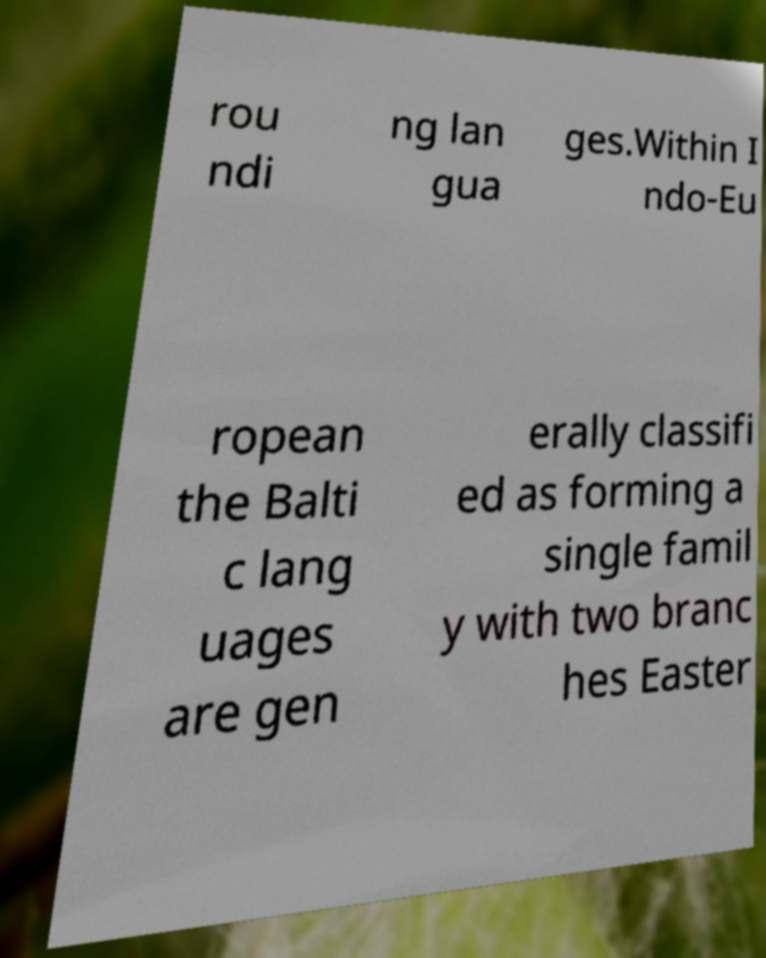Please identify and transcribe the text found in this image. rou ndi ng lan gua ges.Within I ndo-Eu ropean the Balti c lang uages are gen erally classifi ed as forming a single famil y with two branc hes Easter 